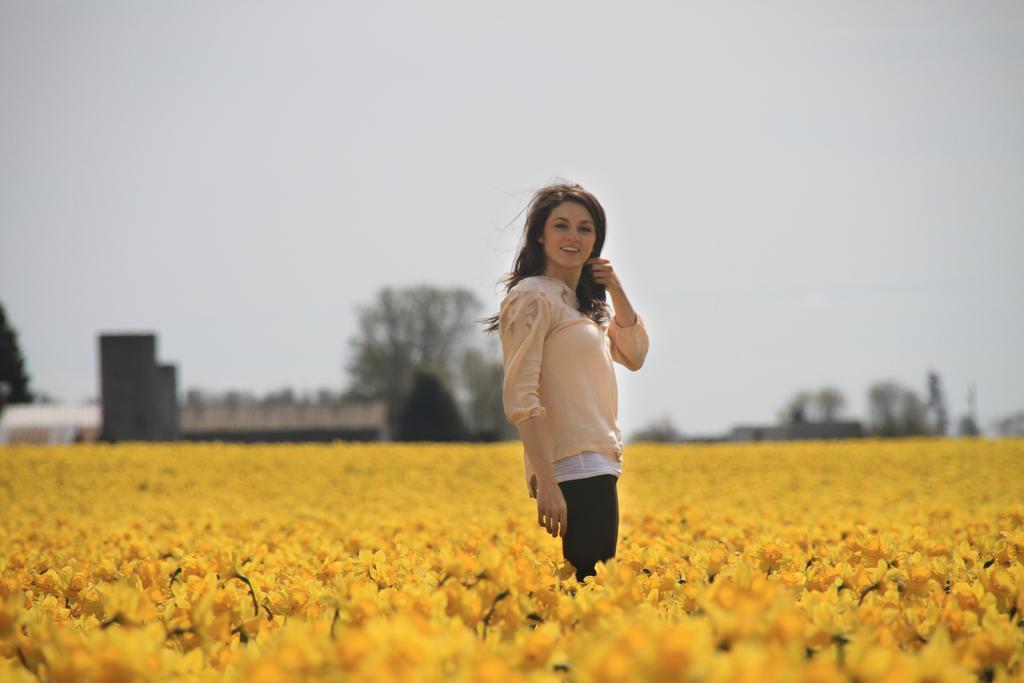Please provide a concise description of this image. In this image we can see a flower garden. A lady is standing in the flower garden. There are few houses and many trees in the image. There is a sky in the image. 